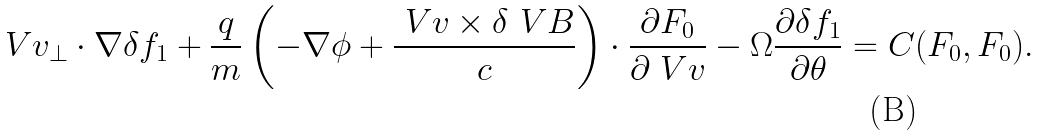Convert formula to latex. <formula><loc_0><loc_0><loc_500><loc_500>\ V { v } _ { \perp } \cdot \nabla \delta f _ { 1 } + \frac { q } { m } \left ( - \nabla \phi + \frac { \ V { v } \times \delta \ V { B } } { c } \right ) \cdot \frac { \partial F _ { 0 } } { \partial \ V { v } } - \Omega \frac { \partial \delta f _ { 1 } } { \partial \theta } = C ( F _ { 0 } , F _ { 0 } ) .</formula> 